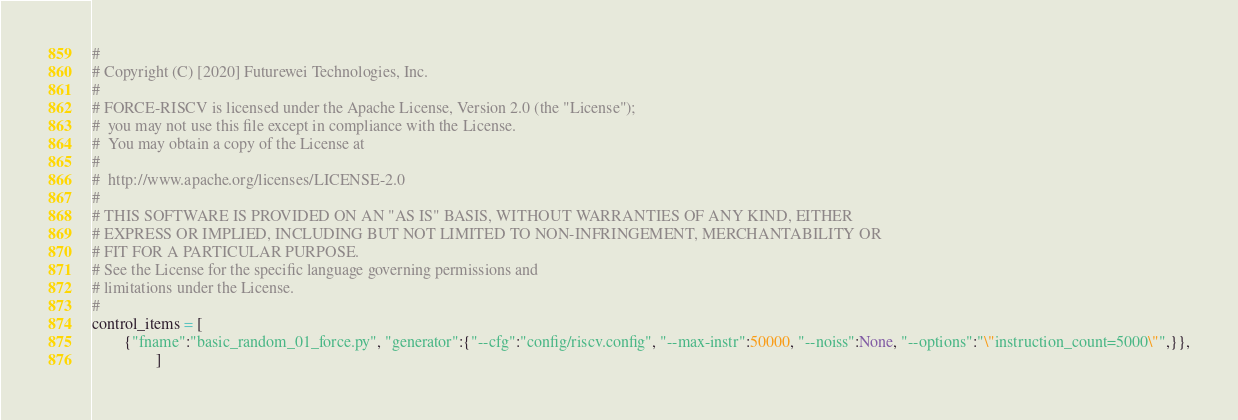Convert code to text. <code><loc_0><loc_0><loc_500><loc_500><_Python_>#
# Copyright (C) [2020] Futurewei Technologies, Inc.
#
# FORCE-RISCV is licensed under the Apache License, Version 2.0 (the "License");
#  you may not use this file except in compliance with the License.
#  You may obtain a copy of the License at
#
#  http://www.apache.org/licenses/LICENSE-2.0
#
# THIS SOFTWARE IS PROVIDED ON AN "AS IS" BASIS, WITHOUT WARRANTIES OF ANY KIND, EITHER
# EXPRESS OR IMPLIED, INCLUDING BUT NOT LIMITED TO NON-INFRINGEMENT, MERCHANTABILITY OR
# FIT FOR A PARTICULAR PURPOSE.
# See the License for the specific language governing permissions and
# limitations under the License.
#
control_items = [
        {"fname":"basic_random_01_force.py", "generator":{"--cfg":"config/riscv.config", "--max-instr":50000, "--noiss":None, "--options":"\"instruction_count=5000\"",}},
                ]
</code> 